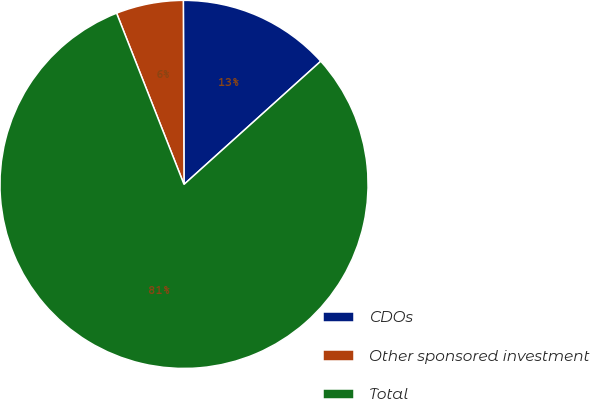Convert chart to OTSL. <chart><loc_0><loc_0><loc_500><loc_500><pie_chart><fcel>CDOs<fcel>Other sponsored investment<fcel>Total<nl><fcel>13.39%<fcel>5.91%<fcel>80.71%<nl></chart> 